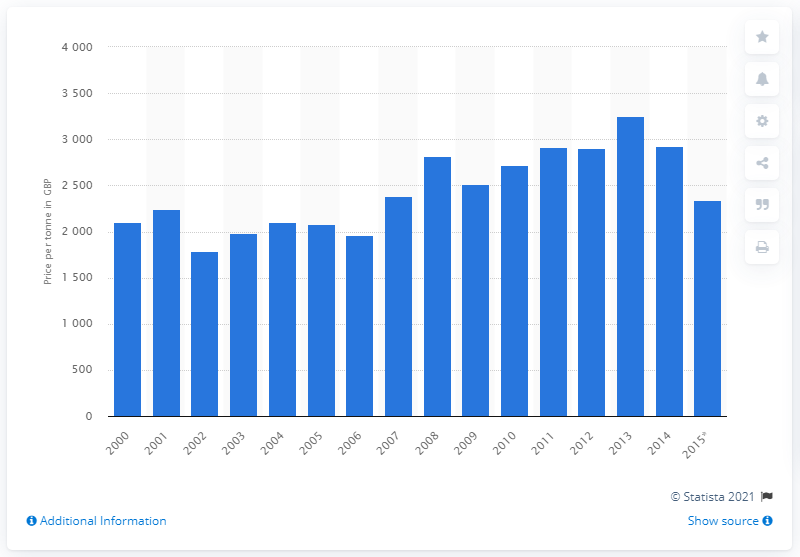List a handful of essential elements in this visual. The price of cheese in British Pound Sterling in 2012 was approximately 2906.25 per tonne. 